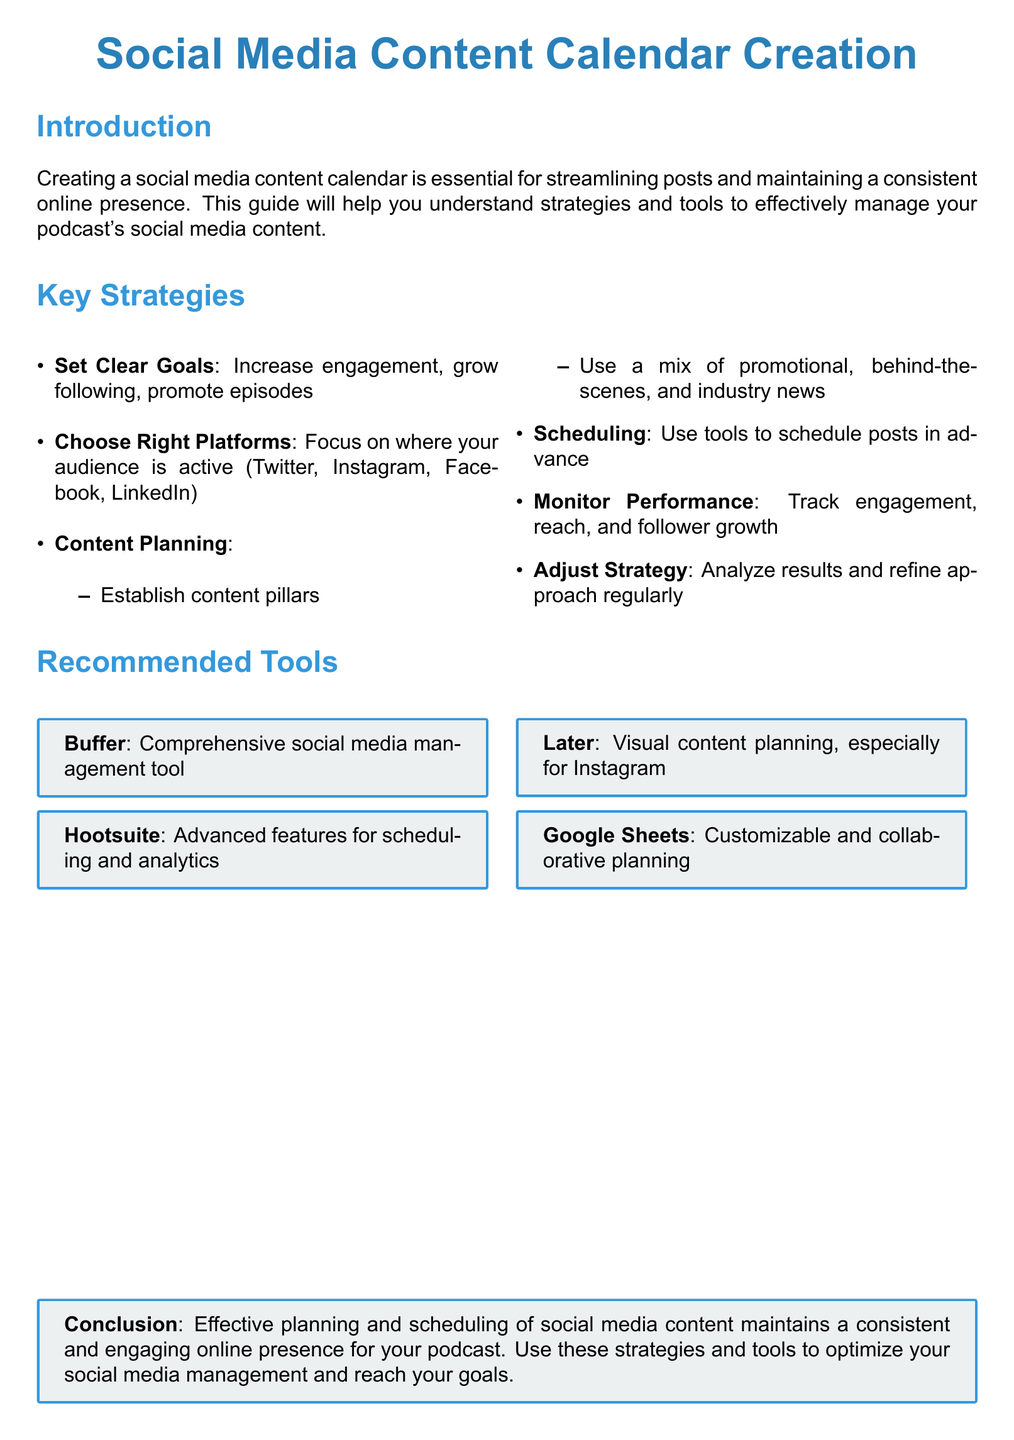What is the main purpose of a social media content calendar? The main purpose is to streamline posts and maintain a consistent online presence.
Answer: To streamline posts What is one recommended tool for social media management? One of the tools listed in the document for social media management is Buffer.
Answer: Buffer Which platforms should the content strategy focus on? The content strategy should focus on platforms where the audience is active, like Twitter, Instagram, Facebook, and LinkedIn.
Answer: Twitter, Instagram, Facebook, LinkedIn How many key strategies are listed in the document? The document lists a total of six key strategies for creating a social media content calendar.
Answer: Six What does the term "content pillars" refer to? Content pillars refer to the main themes or topics around which your content is organized or established.
Answer: Main themes How should performance be monitored according to the guide? Performance should be monitored by tracking engagement, reach, and follower growth.
Answer: Engagement, reach, follower growth What is the conclusion regarding social media content planning? The conclusion emphasizes that effective planning and scheduling maintains a consistent and engaging online presence.
Answer: Consistent and engaging online presence What type of document is this? This document is categorized as a user guide.
Answer: User guide 